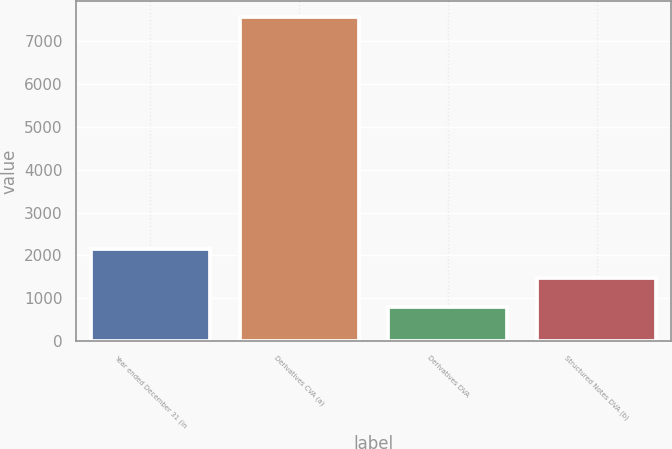<chart> <loc_0><loc_0><loc_500><loc_500><bar_chart><fcel>Year ended December 31 (in<fcel>Derivatives CVA (a)<fcel>Derivatives DVA<fcel>Structured Notes DVA (b)<nl><fcel>2143.4<fcel>7561<fcel>789<fcel>1466.2<nl></chart> 